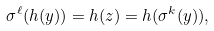<formula> <loc_0><loc_0><loc_500><loc_500>\sigma ^ { \ell } ( h ( y ) ) = h ( z ) = h ( \sigma ^ { k } ( y ) ) ,</formula> 